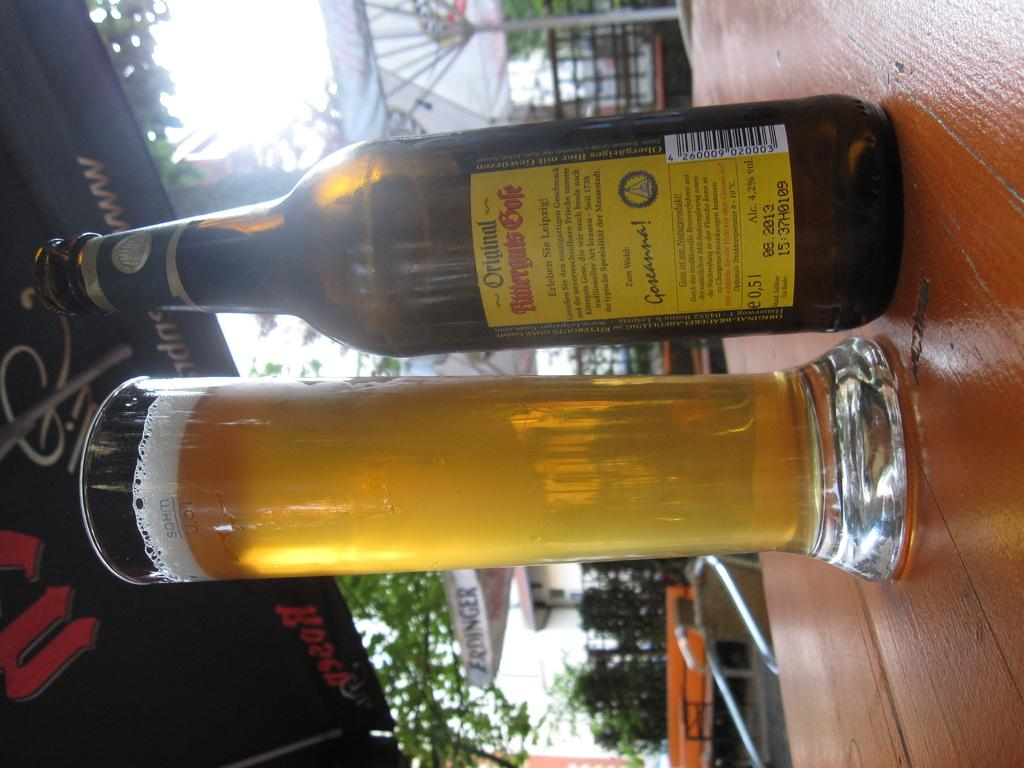<image>
Share a concise interpretation of the image provided. A bottle of Original Rutternuts Gold sitting on a table. 